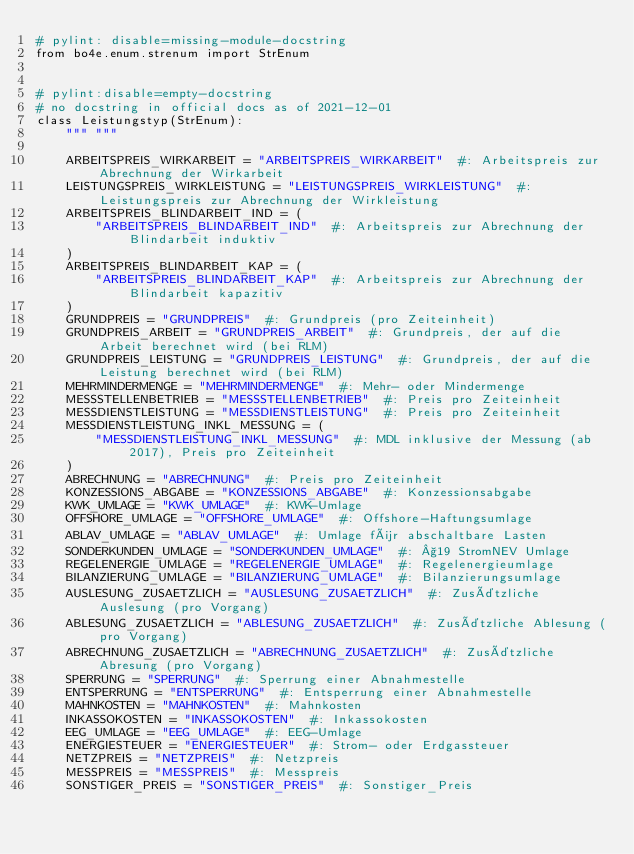<code> <loc_0><loc_0><loc_500><loc_500><_Python_># pylint: disable=missing-module-docstring
from bo4e.enum.strenum import StrEnum


# pylint:disable=empty-docstring
# no docstring in official docs as of 2021-12-01
class Leistungstyp(StrEnum):
    """ """

    ARBEITSPREIS_WIRKARBEIT = "ARBEITSPREIS_WIRKARBEIT"  #: Arbeitspreis zur Abrechnung der Wirkarbeit
    LEISTUNGSPREIS_WIRKLEISTUNG = "LEISTUNGSPREIS_WIRKLEISTUNG"  #: Leistungspreis zur Abrechnung der Wirkleistung
    ARBEITSPREIS_BLINDARBEIT_IND = (
        "ARBEITSPREIS_BLINDARBEIT_IND"  #: Arbeitspreis zur Abrechnung der Blindarbeit induktiv
    )
    ARBEITSPREIS_BLINDARBEIT_KAP = (
        "ARBEITSPREIS_BLINDARBEIT_KAP"  #: Arbeitspreis zur Abrechnung der Blindarbeit kapazitiv
    )
    GRUNDPREIS = "GRUNDPREIS"  #: Grundpreis (pro Zeiteinheit)
    GRUNDPREIS_ARBEIT = "GRUNDPREIS_ARBEIT"  #: Grundpreis, der auf die Arbeit berechnet wird (bei RLM)
    GRUNDPREIS_LEISTUNG = "GRUNDPREIS_LEISTUNG"  #: Grundpreis, der auf die Leistung berechnet wird (bei RLM)
    MEHRMINDERMENGE = "MEHRMINDERMENGE"  #: Mehr- oder Mindermenge
    MESSSTELLENBETRIEB = "MESSSTELLENBETRIEB"  #: Preis pro Zeiteinheit
    MESSDIENSTLEISTUNG = "MESSDIENSTLEISTUNG"  #: Preis pro Zeiteinheit
    MESSDIENSTLEISTUNG_INKL_MESSUNG = (
        "MESSDIENSTLEISTUNG_INKL_MESSUNG"  #: MDL inklusive der Messung (ab 2017), Preis pro Zeiteinheit
    )
    ABRECHNUNG = "ABRECHNUNG"  #: Preis pro Zeiteinheit
    KONZESSIONS_ABGABE = "KONZESSIONS_ABGABE"  #: Konzessionsabgabe
    KWK_UMLAGE = "KWK_UMLAGE"  #: KWK-Umlage
    OFFSHORE_UMLAGE = "OFFSHORE_UMLAGE"  #: Offshore-Haftungsumlage
    ABLAV_UMLAGE = "ABLAV_UMLAGE"  #: Umlage für abschaltbare Lasten
    SONDERKUNDEN_UMLAGE = "SONDERKUNDEN_UMLAGE"  #: §19 StromNEV Umlage
    REGELENERGIE_UMLAGE = "REGELENERGIE_UMLAGE"  #: Regelenergieumlage
    BILANZIERUNG_UMLAGE = "BILANZIERUNG_UMLAGE"  #: Bilanzierungsumlage
    AUSLESUNG_ZUSAETZLICH = "AUSLESUNG_ZUSAETZLICH"  #: Zusätzliche Auslesung (pro Vorgang)
    ABLESUNG_ZUSAETZLICH = "ABLESUNG_ZUSAETZLICH"  #: Zusätzliche Ablesung (pro Vorgang)
    ABRECHNUNG_ZUSAETZLICH = "ABRECHNUNG_ZUSAETZLICH"  #: Zusätzliche Abresung (pro Vorgang)
    SPERRUNG = "SPERRUNG"  #: Sperrung einer Abnahmestelle
    ENTSPERRUNG = "ENTSPERRUNG"  #: Entsperrung einer Abnahmestelle
    MAHNKOSTEN = "MAHNKOSTEN"  #: Mahnkosten
    INKASSOKOSTEN = "INKASSOKOSTEN"  #: Inkassokosten
    EEG_UMLAGE = "EEG_UMLAGE"  #: EEG-Umlage
    ENERGIESTEUER = "ENERGIESTEUER"  #: Strom- oder Erdgassteuer
    NETZPREIS = "NETZPREIS"  #: Netzpreis
    MESSPREIS = "MESSPREIS"  #: Messpreis
    SONSTIGER_PREIS = "SONSTIGER_PREIS"  #: Sonstiger_Preis
</code> 